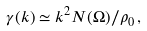Convert formula to latex. <formula><loc_0><loc_0><loc_500><loc_500>\gamma ( { k } ) \simeq k ^ { 2 } N ( \Omega ) / \rho _ { 0 } \, ,</formula> 